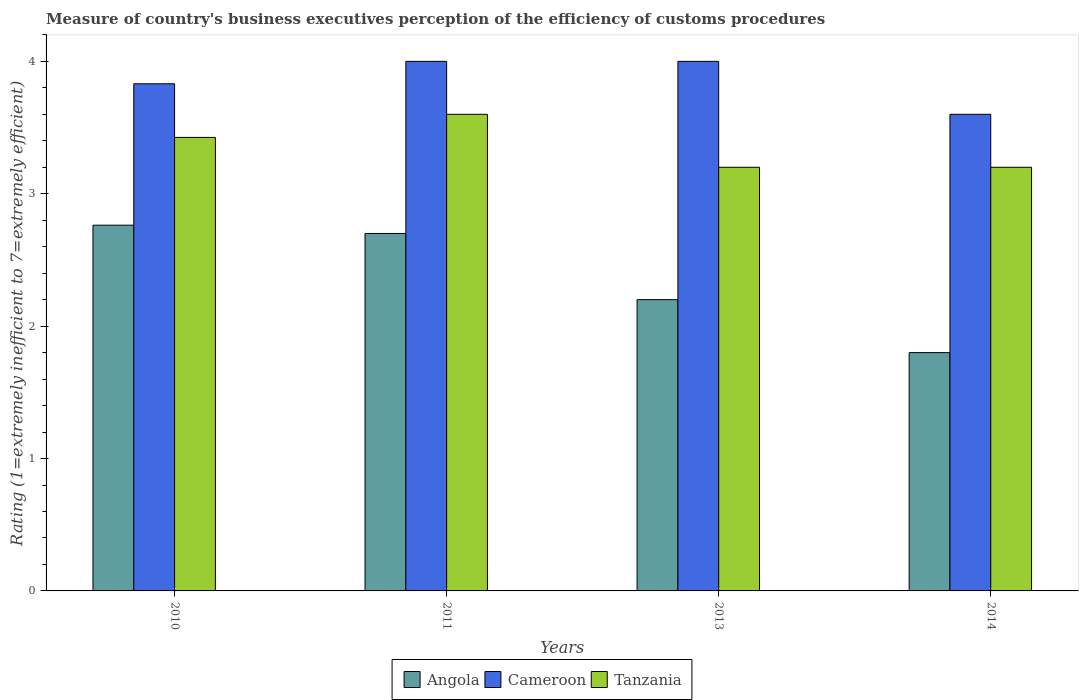How many groups of bars are there?
Your answer should be compact. 4. Are the number of bars per tick equal to the number of legend labels?
Ensure brevity in your answer.  Yes. Are the number of bars on each tick of the X-axis equal?
Keep it short and to the point. Yes. How many bars are there on the 1st tick from the left?
Keep it short and to the point. 3. What is the label of the 1st group of bars from the left?
Provide a succinct answer. 2010. What is the rating of the efficiency of customs procedure in Cameroon in 2011?
Your answer should be very brief. 4. Across all years, what is the maximum rating of the efficiency of customs procedure in Cameroon?
Ensure brevity in your answer.  4. Across all years, what is the minimum rating of the efficiency of customs procedure in Tanzania?
Your answer should be compact. 3.2. In which year was the rating of the efficiency of customs procedure in Tanzania maximum?
Give a very brief answer. 2011. What is the total rating of the efficiency of customs procedure in Angola in the graph?
Your answer should be very brief. 9.46. What is the difference between the rating of the efficiency of customs procedure in Cameroon in 2013 and that in 2014?
Your answer should be very brief. 0.4. What is the difference between the rating of the efficiency of customs procedure in Cameroon in 2011 and the rating of the efficiency of customs procedure in Tanzania in 2010?
Give a very brief answer. 0.57. What is the average rating of the efficiency of customs procedure in Cameroon per year?
Make the answer very short. 3.86. In the year 2013, what is the difference between the rating of the efficiency of customs procedure in Tanzania and rating of the efficiency of customs procedure in Angola?
Provide a short and direct response. 1. What is the ratio of the rating of the efficiency of customs procedure in Tanzania in 2011 to that in 2014?
Your response must be concise. 1.12. Is the rating of the efficiency of customs procedure in Angola in 2011 less than that in 2013?
Make the answer very short. No. What is the difference between the highest and the second highest rating of the efficiency of customs procedure in Angola?
Provide a succinct answer. 0.06. What is the difference between the highest and the lowest rating of the efficiency of customs procedure in Tanzania?
Ensure brevity in your answer.  0.4. Is the sum of the rating of the efficiency of customs procedure in Angola in 2011 and 2014 greater than the maximum rating of the efficiency of customs procedure in Tanzania across all years?
Keep it short and to the point. Yes. What does the 3rd bar from the left in 2014 represents?
Your answer should be very brief. Tanzania. What does the 3rd bar from the right in 2013 represents?
Your answer should be very brief. Angola. How many years are there in the graph?
Ensure brevity in your answer.  4. Are the values on the major ticks of Y-axis written in scientific E-notation?
Keep it short and to the point. No. How are the legend labels stacked?
Provide a short and direct response. Horizontal. What is the title of the graph?
Your answer should be compact. Measure of country's business executives perception of the efficiency of customs procedures. Does "North America" appear as one of the legend labels in the graph?
Provide a short and direct response. No. What is the label or title of the Y-axis?
Your answer should be very brief. Rating (1=extremely inefficient to 7=extremely efficient). What is the Rating (1=extremely inefficient to 7=extremely efficient) in Angola in 2010?
Your answer should be compact. 2.76. What is the Rating (1=extremely inefficient to 7=extremely efficient) in Cameroon in 2010?
Your response must be concise. 3.83. What is the Rating (1=extremely inefficient to 7=extremely efficient) in Tanzania in 2010?
Ensure brevity in your answer.  3.43. What is the Rating (1=extremely inefficient to 7=extremely efficient) of Angola in 2011?
Give a very brief answer. 2.7. What is the Rating (1=extremely inefficient to 7=extremely efficient) in Angola in 2013?
Provide a succinct answer. 2.2. What is the Rating (1=extremely inefficient to 7=extremely efficient) in Tanzania in 2013?
Provide a short and direct response. 3.2. Across all years, what is the maximum Rating (1=extremely inefficient to 7=extremely efficient) of Angola?
Your answer should be very brief. 2.76. Across all years, what is the maximum Rating (1=extremely inefficient to 7=extremely efficient) of Tanzania?
Offer a terse response. 3.6. Across all years, what is the minimum Rating (1=extremely inefficient to 7=extremely efficient) of Tanzania?
Keep it short and to the point. 3.2. What is the total Rating (1=extremely inefficient to 7=extremely efficient) in Angola in the graph?
Keep it short and to the point. 9.46. What is the total Rating (1=extremely inefficient to 7=extremely efficient) of Cameroon in the graph?
Keep it short and to the point. 15.43. What is the total Rating (1=extremely inefficient to 7=extremely efficient) in Tanzania in the graph?
Make the answer very short. 13.43. What is the difference between the Rating (1=extremely inefficient to 7=extremely efficient) in Angola in 2010 and that in 2011?
Your answer should be very brief. 0.06. What is the difference between the Rating (1=extremely inefficient to 7=extremely efficient) in Cameroon in 2010 and that in 2011?
Make the answer very short. -0.17. What is the difference between the Rating (1=extremely inefficient to 7=extremely efficient) in Tanzania in 2010 and that in 2011?
Offer a very short reply. -0.17. What is the difference between the Rating (1=extremely inefficient to 7=extremely efficient) of Angola in 2010 and that in 2013?
Provide a short and direct response. 0.56. What is the difference between the Rating (1=extremely inefficient to 7=extremely efficient) in Cameroon in 2010 and that in 2013?
Provide a short and direct response. -0.17. What is the difference between the Rating (1=extremely inefficient to 7=extremely efficient) of Tanzania in 2010 and that in 2013?
Provide a short and direct response. 0.23. What is the difference between the Rating (1=extremely inefficient to 7=extremely efficient) of Angola in 2010 and that in 2014?
Your answer should be compact. 0.96. What is the difference between the Rating (1=extremely inefficient to 7=extremely efficient) in Cameroon in 2010 and that in 2014?
Keep it short and to the point. 0.23. What is the difference between the Rating (1=extremely inefficient to 7=extremely efficient) in Tanzania in 2010 and that in 2014?
Provide a succinct answer. 0.23. What is the difference between the Rating (1=extremely inefficient to 7=extremely efficient) of Angola in 2011 and that in 2014?
Your answer should be compact. 0.9. What is the difference between the Rating (1=extremely inefficient to 7=extremely efficient) of Cameroon in 2011 and that in 2014?
Keep it short and to the point. 0.4. What is the difference between the Rating (1=extremely inefficient to 7=extremely efficient) of Angola in 2013 and that in 2014?
Your answer should be very brief. 0.4. What is the difference between the Rating (1=extremely inefficient to 7=extremely efficient) in Tanzania in 2013 and that in 2014?
Provide a succinct answer. 0. What is the difference between the Rating (1=extremely inefficient to 7=extremely efficient) of Angola in 2010 and the Rating (1=extremely inefficient to 7=extremely efficient) of Cameroon in 2011?
Your answer should be compact. -1.24. What is the difference between the Rating (1=extremely inefficient to 7=extremely efficient) in Angola in 2010 and the Rating (1=extremely inefficient to 7=extremely efficient) in Tanzania in 2011?
Make the answer very short. -0.84. What is the difference between the Rating (1=extremely inefficient to 7=extremely efficient) in Cameroon in 2010 and the Rating (1=extremely inefficient to 7=extremely efficient) in Tanzania in 2011?
Provide a succinct answer. 0.23. What is the difference between the Rating (1=extremely inefficient to 7=extremely efficient) of Angola in 2010 and the Rating (1=extremely inefficient to 7=extremely efficient) of Cameroon in 2013?
Offer a very short reply. -1.24. What is the difference between the Rating (1=extremely inefficient to 7=extremely efficient) of Angola in 2010 and the Rating (1=extremely inefficient to 7=extremely efficient) of Tanzania in 2013?
Your response must be concise. -0.44. What is the difference between the Rating (1=extremely inefficient to 7=extremely efficient) in Cameroon in 2010 and the Rating (1=extremely inefficient to 7=extremely efficient) in Tanzania in 2013?
Make the answer very short. 0.63. What is the difference between the Rating (1=extremely inefficient to 7=extremely efficient) in Angola in 2010 and the Rating (1=extremely inefficient to 7=extremely efficient) in Cameroon in 2014?
Make the answer very short. -0.84. What is the difference between the Rating (1=extremely inefficient to 7=extremely efficient) in Angola in 2010 and the Rating (1=extremely inefficient to 7=extremely efficient) in Tanzania in 2014?
Offer a terse response. -0.44. What is the difference between the Rating (1=extremely inefficient to 7=extremely efficient) of Cameroon in 2010 and the Rating (1=extremely inefficient to 7=extremely efficient) of Tanzania in 2014?
Your answer should be compact. 0.63. What is the difference between the Rating (1=extremely inefficient to 7=extremely efficient) of Cameroon in 2011 and the Rating (1=extremely inefficient to 7=extremely efficient) of Tanzania in 2013?
Give a very brief answer. 0.8. What is the difference between the Rating (1=extremely inefficient to 7=extremely efficient) of Cameroon in 2011 and the Rating (1=extremely inefficient to 7=extremely efficient) of Tanzania in 2014?
Ensure brevity in your answer.  0.8. What is the difference between the Rating (1=extremely inefficient to 7=extremely efficient) of Angola in 2013 and the Rating (1=extremely inefficient to 7=extremely efficient) of Cameroon in 2014?
Give a very brief answer. -1.4. What is the difference between the Rating (1=extremely inefficient to 7=extremely efficient) of Angola in 2013 and the Rating (1=extremely inefficient to 7=extremely efficient) of Tanzania in 2014?
Give a very brief answer. -1. What is the average Rating (1=extremely inefficient to 7=extremely efficient) of Angola per year?
Provide a short and direct response. 2.37. What is the average Rating (1=extremely inefficient to 7=extremely efficient) in Cameroon per year?
Provide a succinct answer. 3.86. What is the average Rating (1=extremely inefficient to 7=extremely efficient) of Tanzania per year?
Offer a terse response. 3.36. In the year 2010, what is the difference between the Rating (1=extremely inefficient to 7=extremely efficient) of Angola and Rating (1=extremely inefficient to 7=extremely efficient) of Cameroon?
Give a very brief answer. -1.07. In the year 2010, what is the difference between the Rating (1=extremely inefficient to 7=extremely efficient) in Angola and Rating (1=extremely inefficient to 7=extremely efficient) in Tanzania?
Provide a short and direct response. -0.66. In the year 2010, what is the difference between the Rating (1=extremely inefficient to 7=extremely efficient) of Cameroon and Rating (1=extremely inefficient to 7=extremely efficient) of Tanzania?
Offer a very short reply. 0.41. In the year 2011, what is the difference between the Rating (1=extremely inefficient to 7=extremely efficient) in Angola and Rating (1=extremely inefficient to 7=extremely efficient) in Cameroon?
Provide a short and direct response. -1.3. In the year 2011, what is the difference between the Rating (1=extremely inefficient to 7=extremely efficient) of Cameroon and Rating (1=extremely inefficient to 7=extremely efficient) of Tanzania?
Your answer should be very brief. 0.4. In the year 2013, what is the difference between the Rating (1=extremely inefficient to 7=extremely efficient) in Angola and Rating (1=extremely inefficient to 7=extremely efficient) in Tanzania?
Keep it short and to the point. -1. In the year 2013, what is the difference between the Rating (1=extremely inefficient to 7=extremely efficient) in Cameroon and Rating (1=extremely inefficient to 7=extremely efficient) in Tanzania?
Ensure brevity in your answer.  0.8. In the year 2014, what is the difference between the Rating (1=extremely inefficient to 7=extremely efficient) of Angola and Rating (1=extremely inefficient to 7=extremely efficient) of Tanzania?
Offer a terse response. -1.4. In the year 2014, what is the difference between the Rating (1=extremely inefficient to 7=extremely efficient) in Cameroon and Rating (1=extremely inefficient to 7=extremely efficient) in Tanzania?
Your answer should be compact. 0.4. What is the ratio of the Rating (1=extremely inefficient to 7=extremely efficient) of Angola in 2010 to that in 2011?
Your answer should be very brief. 1.02. What is the ratio of the Rating (1=extremely inefficient to 7=extremely efficient) in Cameroon in 2010 to that in 2011?
Provide a succinct answer. 0.96. What is the ratio of the Rating (1=extremely inefficient to 7=extremely efficient) in Tanzania in 2010 to that in 2011?
Give a very brief answer. 0.95. What is the ratio of the Rating (1=extremely inefficient to 7=extremely efficient) of Angola in 2010 to that in 2013?
Ensure brevity in your answer.  1.26. What is the ratio of the Rating (1=extremely inefficient to 7=extremely efficient) of Cameroon in 2010 to that in 2013?
Keep it short and to the point. 0.96. What is the ratio of the Rating (1=extremely inefficient to 7=extremely efficient) of Tanzania in 2010 to that in 2013?
Your response must be concise. 1.07. What is the ratio of the Rating (1=extremely inefficient to 7=extremely efficient) in Angola in 2010 to that in 2014?
Offer a very short reply. 1.53. What is the ratio of the Rating (1=extremely inefficient to 7=extremely efficient) of Cameroon in 2010 to that in 2014?
Offer a terse response. 1.06. What is the ratio of the Rating (1=extremely inefficient to 7=extremely efficient) in Tanzania in 2010 to that in 2014?
Offer a terse response. 1.07. What is the ratio of the Rating (1=extremely inefficient to 7=extremely efficient) of Angola in 2011 to that in 2013?
Your answer should be very brief. 1.23. What is the ratio of the Rating (1=extremely inefficient to 7=extremely efficient) in Tanzania in 2011 to that in 2013?
Keep it short and to the point. 1.12. What is the ratio of the Rating (1=extremely inefficient to 7=extremely efficient) of Cameroon in 2011 to that in 2014?
Offer a very short reply. 1.11. What is the ratio of the Rating (1=extremely inefficient to 7=extremely efficient) of Tanzania in 2011 to that in 2014?
Your response must be concise. 1.12. What is the ratio of the Rating (1=extremely inefficient to 7=extremely efficient) in Angola in 2013 to that in 2014?
Your response must be concise. 1.22. What is the ratio of the Rating (1=extremely inefficient to 7=extremely efficient) in Cameroon in 2013 to that in 2014?
Provide a short and direct response. 1.11. What is the difference between the highest and the second highest Rating (1=extremely inefficient to 7=extremely efficient) of Angola?
Your response must be concise. 0.06. What is the difference between the highest and the second highest Rating (1=extremely inefficient to 7=extremely efficient) in Cameroon?
Provide a short and direct response. 0. What is the difference between the highest and the second highest Rating (1=extremely inefficient to 7=extremely efficient) of Tanzania?
Provide a succinct answer. 0.17. What is the difference between the highest and the lowest Rating (1=extremely inefficient to 7=extremely efficient) in Angola?
Ensure brevity in your answer.  0.96. 